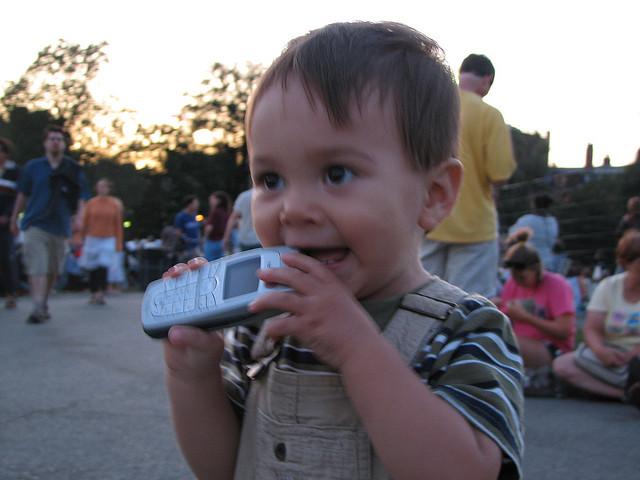Is the child using the phone correctly?
Answer briefly. No. What does the baby have in his mouth?
Quick response, please. Phone. What color are the boy's overalls?
Keep it brief. Tan. Why is the boy looking so serious?
Write a very short answer. Can't tell. Is this person old?
Keep it brief. No. Is the cell phone edible?
Give a very brief answer. No. 